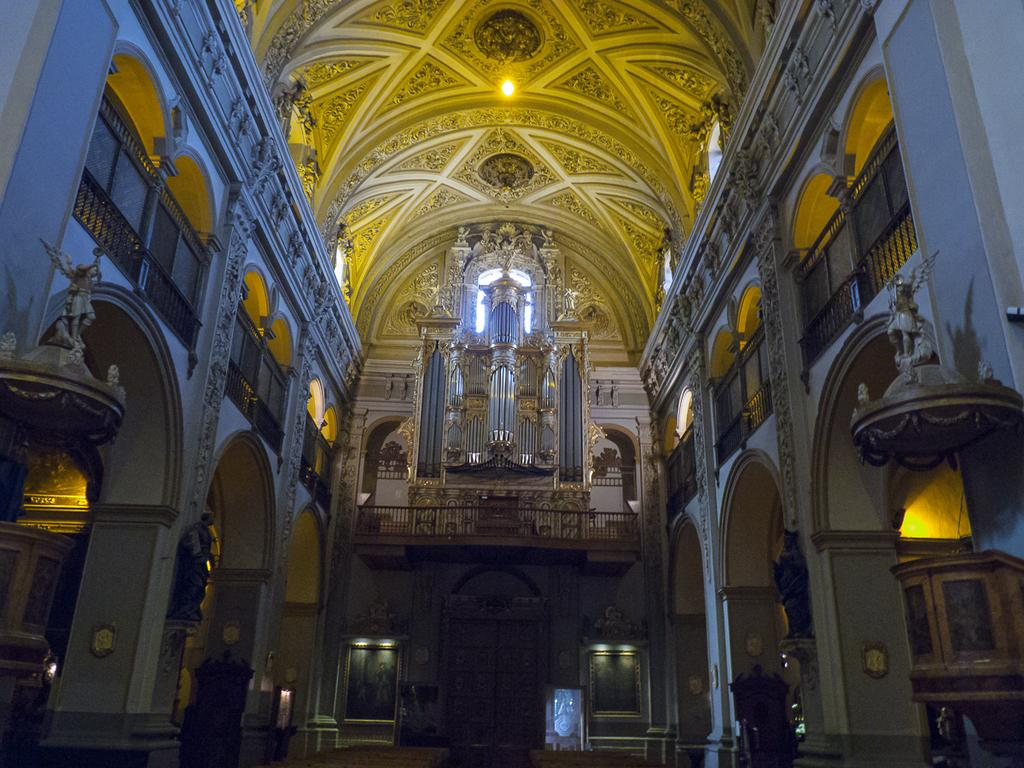What type of building is shown in the image? The image shows the inside view of a parish building. What decorative elements can be seen in the parish building? There are sculptures in the parish building. How can people enter or exit the parish building? There are doors in the parish building. What provides illumination in the parish building? There are lights and chandeliers in the parish building. What hobbies are the parishioners participating in during the service? The image does not show any parishioners or their hobbies; it only shows the interior of the parish building. Can you hear the drum being played in the image? There is no drum or any sound present in the image, as it is a still photograph. 